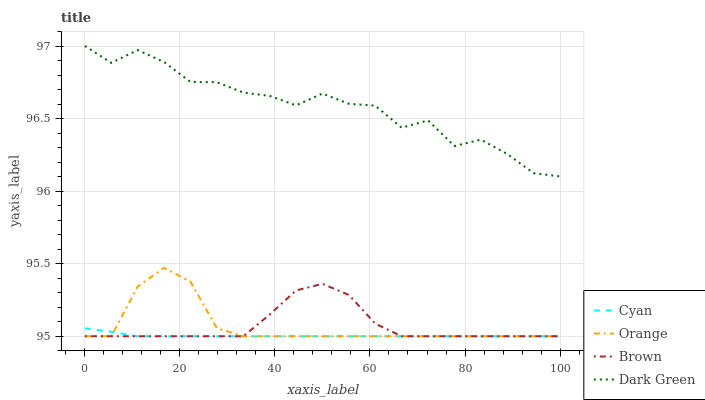Does Cyan have the minimum area under the curve?
Answer yes or no. Yes. Does Dark Green have the maximum area under the curve?
Answer yes or no. Yes. Does Dark Green have the minimum area under the curve?
Answer yes or no. No. Does Cyan have the maximum area under the curve?
Answer yes or no. No. Is Cyan the smoothest?
Answer yes or no. Yes. Is Dark Green the roughest?
Answer yes or no. Yes. Is Dark Green the smoothest?
Answer yes or no. No. Is Cyan the roughest?
Answer yes or no. No. Does Orange have the lowest value?
Answer yes or no. Yes. Does Dark Green have the lowest value?
Answer yes or no. No. Does Dark Green have the highest value?
Answer yes or no. Yes. Does Cyan have the highest value?
Answer yes or no. No. Is Brown less than Dark Green?
Answer yes or no. Yes. Is Dark Green greater than Orange?
Answer yes or no. Yes. Does Brown intersect Cyan?
Answer yes or no. Yes. Is Brown less than Cyan?
Answer yes or no. No. Is Brown greater than Cyan?
Answer yes or no. No. Does Brown intersect Dark Green?
Answer yes or no. No. 